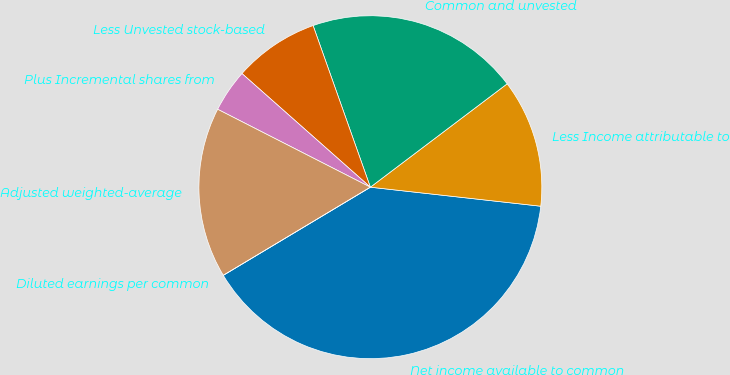<chart> <loc_0><loc_0><loc_500><loc_500><pie_chart><fcel>Net income available to common<fcel>Less Income attributable to<fcel>Common and unvested<fcel>Less Unvested stock-based<fcel>Plus Incremental shares from<fcel>Adjusted weighted-average<fcel>Diluted earnings per common<nl><fcel>39.64%<fcel>12.07%<fcel>20.12%<fcel>8.05%<fcel>4.02%<fcel>16.1%<fcel>0.0%<nl></chart> 